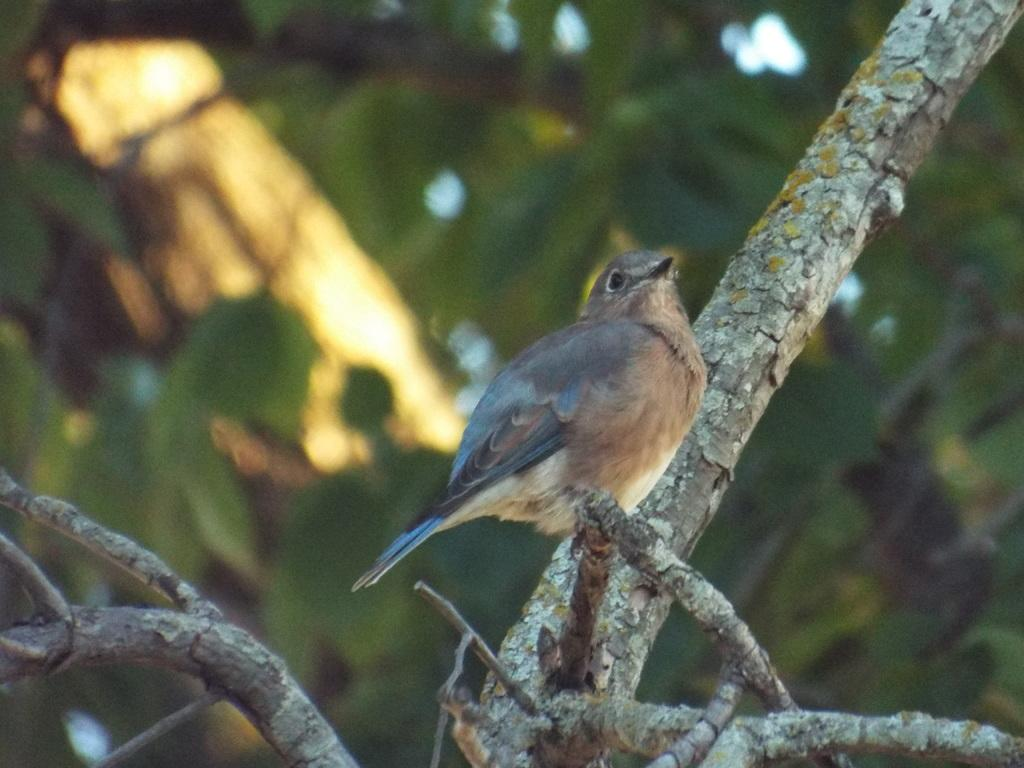What type of animal can be seen in the image? There is a bird in the image. Where is the bird located? The bird is on a stem. In which direction is the bird facing? The bird is facing towards the right side. What can be seen in the background of the image? There are leaves visible in the background of the image. What type of chair is the bird sitting on in the image? There is no chair present in the image; the bird is on a stem. 